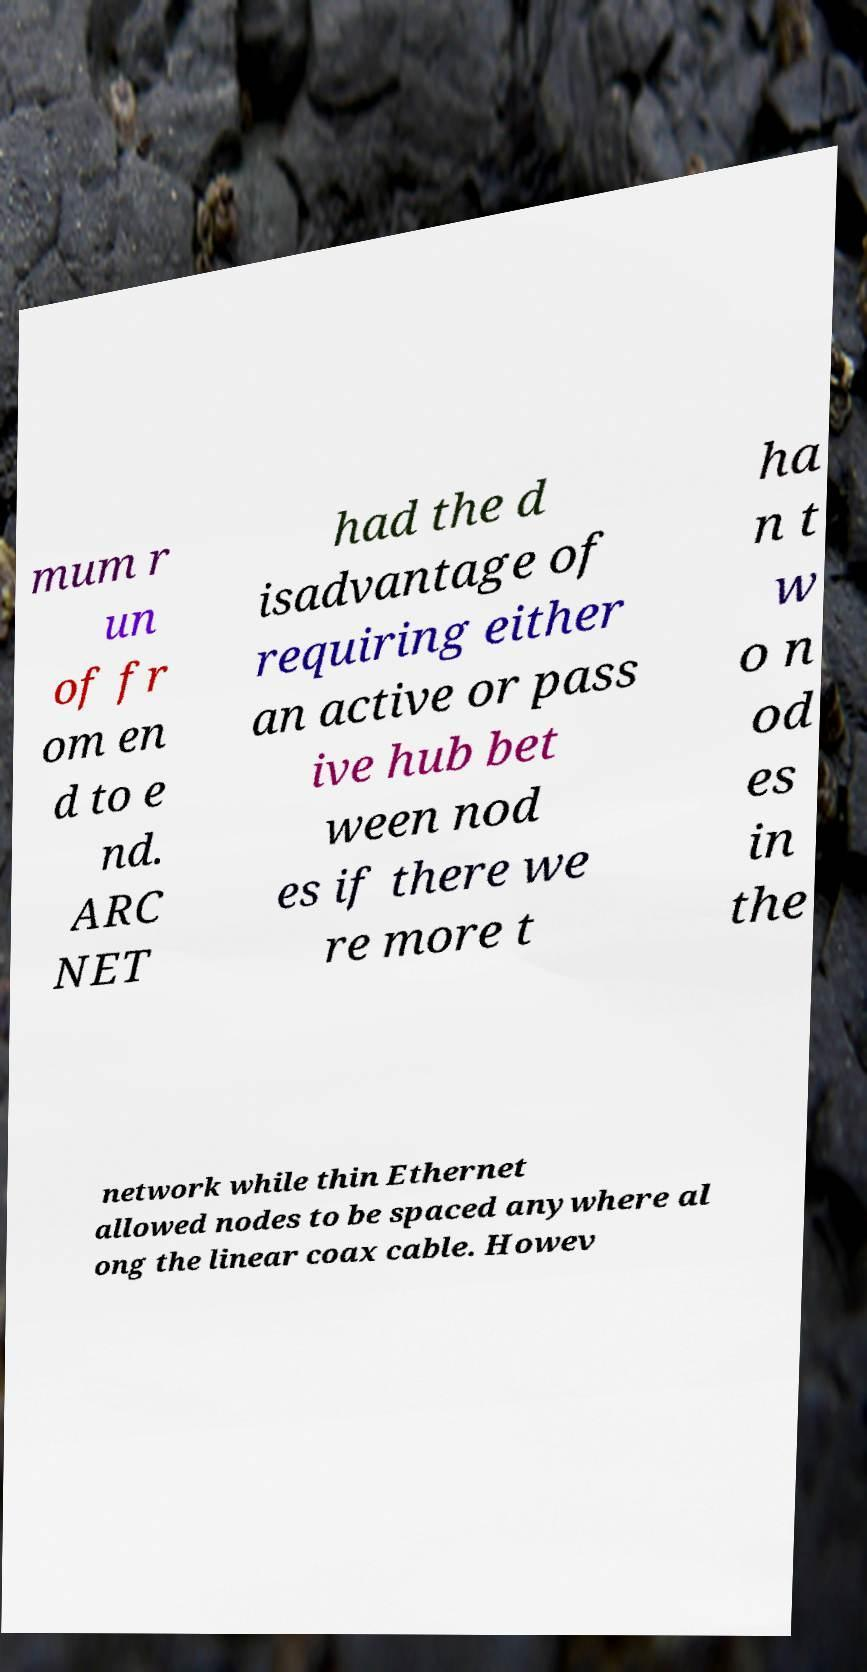I need the written content from this picture converted into text. Can you do that? mum r un of fr om en d to e nd. ARC NET had the d isadvantage of requiring either an active or pass ive hub bet ween nod es if there we re more t ha n t w o n od es in the network while thin Ethernet allowed nodes to be spaced anywhere al ong the linear coax cable. Howev 